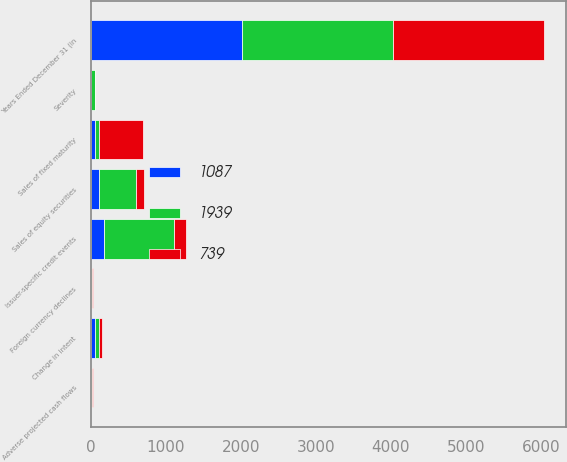Convert chart. <chart><loc_0><loc_0><loc_500><loc_500><stacked_bar_chart><ecel><fcel>Years Ended December 31 (in<fcel>Sales of fixed maturity<fcel>Sales of equity securities<fcel>Severity<fcel>Change in intent<fcel>Foreign currency declines<fcel>Issuer-specific credit events<fcel>Adverse projected cash flows<nl><fcel>739<fcel>2014<fcel>585<fcel>111<fcel>3<fcel>40<fcel>19<fcel>169<fcel>16<nl><fcel>1087<fcel>2013<fcel>55<fcel>111<fcel>6<fcel>48<fcel>1<fcel>170<fcel>7<nl><fcel>1939<fcel>2012<fcel>55<fcel>484<fcel>44<fcel>62<fcel>8<fcel>931<fcel>5<nl></chart> 